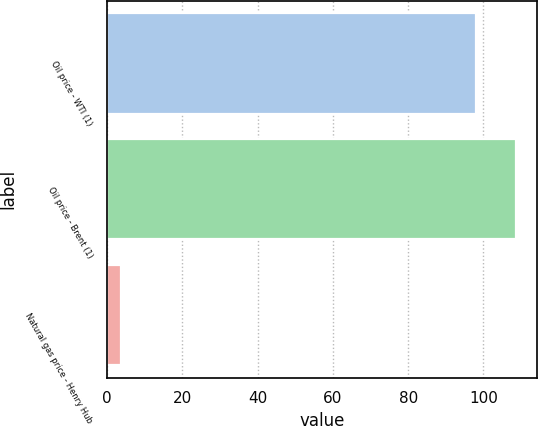Convert chart to OTSL. <chart><loc_0><loc_0><loc_500><loc_500><bar_chart><fcel>Oil price - WTI (1)<fcel>Oil price - Brent (1)<fcel>Natural gas price - Henry Hub<nl><fcel>97.99<fcel>108.71<fcel>3.73<nl></chart> 